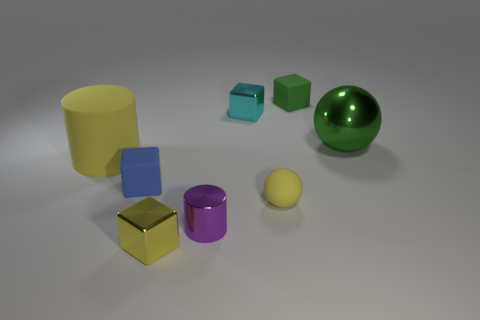There is a tiny shiny object that is the same color as the big cylinder; what shape is it?
Ensure brevity in your answer.  Cube. There is a matte object that is right of the tiny sphere; is its color the same as the block that is in front of the yellow sphere?
Offer a terse response. No. How many rubber things are both left of the yellow block and on the right side of the small blue block?
Offer a terse response. 0. What is the small cyan block made of?
Give a very brief answer. Metal. The blue object that is the same size as the cyan cube is what shape?
Offer a very short reply. Cube. Is the yellow object that is in front of the purple metallic thing made of the same material as the cylinder that is in front of the small blue rubber thing?
Your response must be concise. Yes. How many large green matte cylinders are there?
Provide a short and direct response. 0. How many yellow rubber things have the same shape as the large metal thing?
Provide a short and direct response. 1. Do the big yellow thing and the blue object have the same shape?
Provide a succinct answer. No. The green rubber block is what size?
Offer a very short reply. Small. 